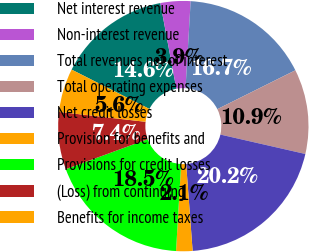Convert chart. <chart><loc_0><loc_0><loc_500><loc_500><pie_chart><fcel>Net interest revenue<fcel>Non-interest revenue<fcel>Total revenues net of interest<fcel>Total operating expenses<fcel>Net credit losses<fcel>Provision for benefits and<fcel>Provisions for credit losses<fcel>(Loss) from continuing<fcel>Benefits for income taxes<nl><fcel>14.61%<fcel>3.87%<fcel>16.71%<fcel>10.93%<fcel>20.24%<fcel>2.11%<fcel>18.48%<fcel>7.4%<fcel>5.64%<nl></chart> 